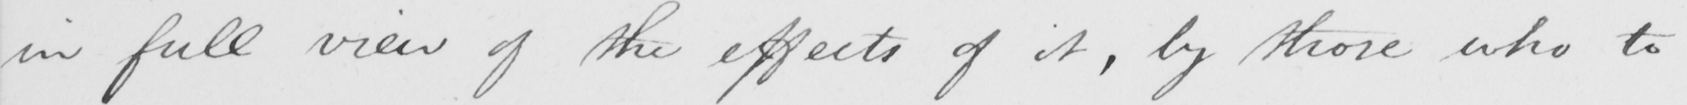Can you read and transcribe this handwriting? in full view of the effect of it , by those who to 